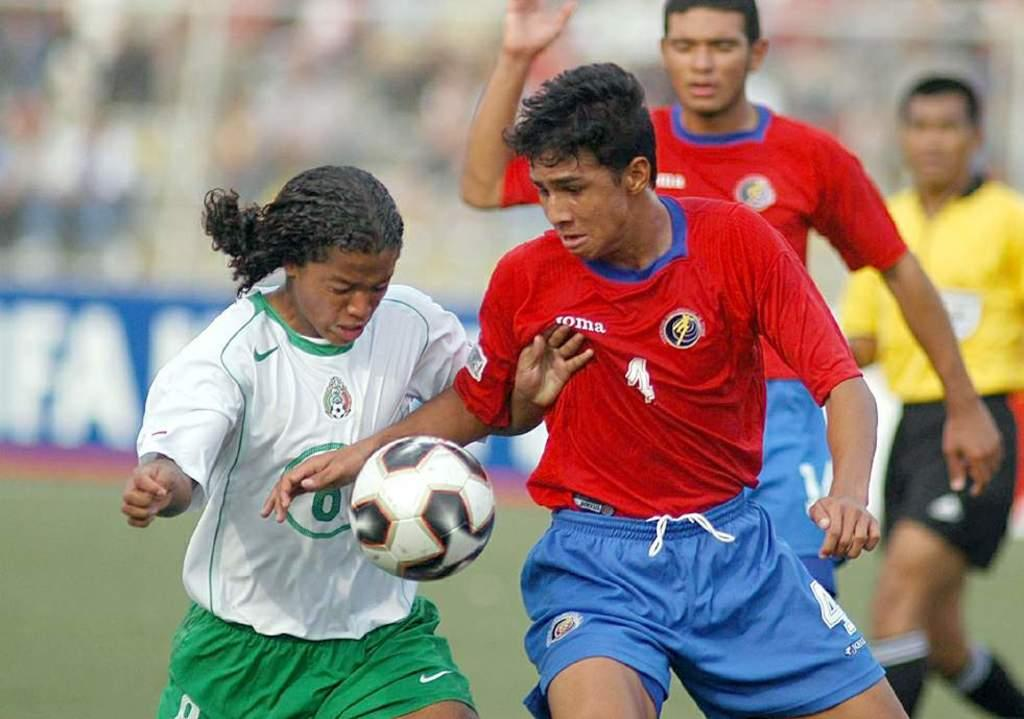<image>
Describe the image concisely. Some people play football - the number one is visible on a shirt. 